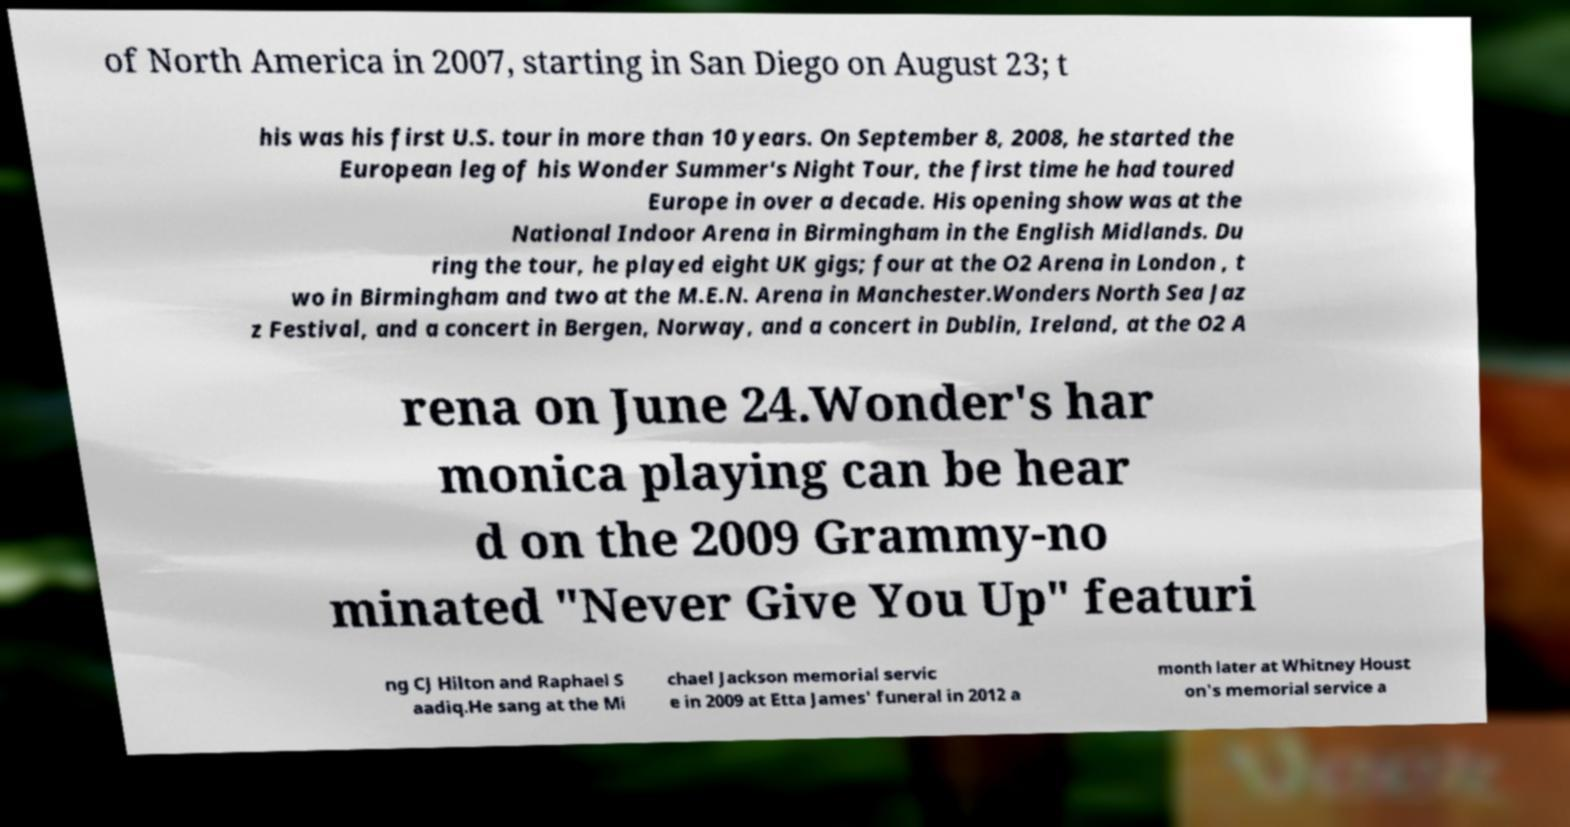Please read and relay the text visible in this image. What does it say? of North America in 2007, starting in San Diego on August 23; t his was his first U.S. tour in more than 10 years. On September 8, 2008, he started the European leg of his Wonder Summer's Night Tour, the first time he had toured Europe in over a decade. His opening show was at the National Indoor Arena in Birmingham in the English Midlands. Du ring the tour, he played eight UK gigs; four at the O2 Arena in London , t wo in Birmingham and two at the M.E.N. Arena in Manchester.Wonders North Sea Jaz z Festival, and a concert in Bergen, Norway, and a concert in Dublin, Ireland, at the O2 A rena on June 24.Wonder's har monica playing can be hear d on the 2009 Grammy-no minated "Never Give You Up" featuri ng CJ Hilton and Raphael S aadiq.He sang at the Mi chael Jackson memorial servic e in 2009 at Etta James' funeral in 2012 a month later at Whitney Houst on's memorial service a 